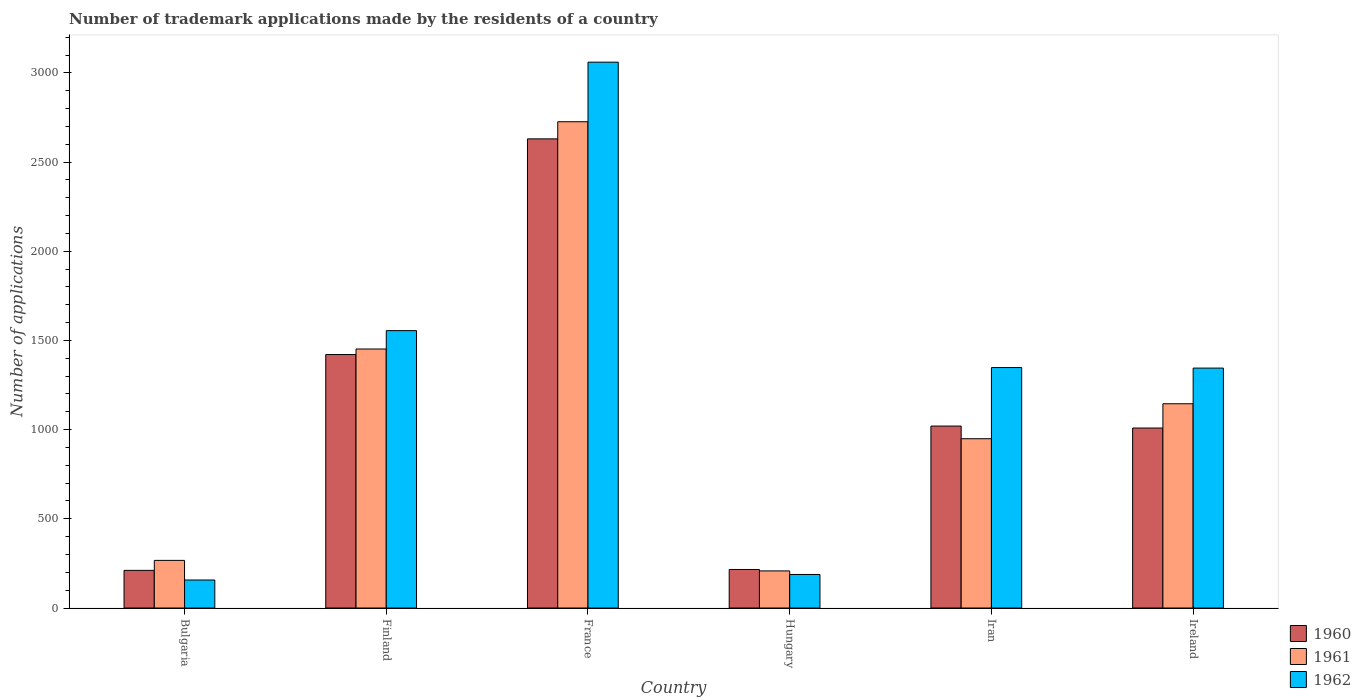How many different coloured bars are there?
Provide a short and direct response. 3. How many groups of bars are there?
Provide a short and direct response. 6. What is the label of the 1st group of bars from the left?
Keep it short and to the point. Bulgaria. What is the number of trademark applications made by the residents in 1961 in Iran?
Make the answer very short. 949. Across all countries, what is the maximum number of trademark applications made by the residents in 1962?
Ensure brevity in your answer.  3060. Across all countries, what is the minimum number of trademark applications made by the residents in 1962?
Your response must be concise. 157. In which country was the number of trademark applications made by the residents in 1961 maximum?
Your answer should be very brief. France. In which country was the number of trademark applications made by the residents in 1960 minimum?
Offer a terse response. Bulgaria. What is the total number of trademark applications made by the residents in 1960 in the graph?
Provide a short and direct response. 6507. What is the difference between the number of trademark applications made by the residents in 1961 in Bulgaria and that in Ireland?
Your answer should be compact. -878. What is the difference between the number of trademark applications made by the residents in 1961 in France and the number of trademark applications made by the residents in 1960 in Finland?
Your answer should be compact. 1305. What is the average number of trademark applications made by the residents in 1962 per country?
Offer a terse response. 1275.5. What is the difference between the number of trademark applications made by the residents of/in 1961 and number of trademark applications made by the residents of/in 1962 in Ireland?
Provide a short and direct response. -200. In how many countries, is the number of trademark applications made by the residents in 1962 greater than 800?
Offer a terse response. 4. What is the ratio of the number of trademark applications made by the residents in 1960 in Bulgaria to that in Finland?
Offer a very short reply. 0.15. Is the number of trademark applications made by the residents in 1962 in France less than that in Hungary?
Your response must be concise. No. What is the difference between the highest and the second highest number of trademark applications made by the residents in 1960?
Your answer should be very brief. -401. What is the difference between the highest and the lowest number of trademark applications made by the residents in 1960?
Keep it short and to the point. 2419. What does the 3rd bar from the right in Hungary represents?
Offer a terse response. 1960. Is it the case that in every country, the sum of the number of trademark applications made by the residents in 1962 and number of trademark applications made by the residents in 1961 is greater than the number of trademark applications made by the residents in 1960?
Your answer should be very brief. Yes. What is the difference between two consecutive major ticks on the Y-axis?
Provide a succinct answer. 500. Does the graph contain any zero values?
Your response must be concise. No. How are the legend labels stacked?
Provide a succinct answer. Vertical. What is the title of the graph?
Provide a succinct answer. Number of trademark applications made by the residents of a country. Does "2007" appear as one of the legend labels in the graph?
Make the answer very short. No. What is the label or title of the X-axis?
Keep it short and to the point. Country. What is the label or title of the Y-axis?
Your answer should be compact. Number of applications. What is the Number of applications in 1960 in Bulgaria?
Provide a succinct answer. 211. What is the Number of applications of 1961 in Bulgaria?
Ensure brevity in your answer.  267. What is the Number of applications of 1962 in Bulgaria?
Make the answer very short. 157. What is the Number of applications in 1960 in Finland?
Ensure brevity in your answer.  1421. What is the Number of applications in 1961 in Finland?
Make the answer very short. 1452. What is the Number of applications of 1962 in Finland?
Give a very brief answer. 1555. What is the Number of applications of 1960 in France?
Offer a terse response. 2630. What is the Number of applications in 1961 in France?
Make the answer very short. 2726. What is the Number of applications of 1962 in France?
Provide a succinct answer. 3060. What is the Number of applications of 1960 in Hungary?
Make the answer very short. 216. What is the Number of applications in 1961 in Hungary?
Your response must be concise. 208. What is the Number of applications of 1962 in Hungary?
Provide a succinct answer. 188. What is the Number of applications in 1960 in Iran?
Make the answer very short. 1020. What is the Number of applications in 1961 in Iran?
Keep it short and to the point. 949. What is the Number of applications of 1962 in Iran?
Provide a short and direct response. 1348. What is the Number of applications in 1960 in Ireland?
Make the answer very short. 1009. What is the Number of applications of 1961 in Ireland?
Ensure brevity in your answer.  1145. What is the Number of applications in 1962 in Ireland?
Offer a very short reply. 1345. Across all countries, what is the maximum Number of applications of 1960?
Make the answer very short. 2630. Across all countries, what is the maximum Number of applications in 1961?
Provide a short and direct response. 2726. Across all countries, what is the maximum Number of applications in 1962?
Offer a very short reply. 3060. Across all countries, what is the minimum Number of applications of 1960?
Offer a very short reply. 211. Across all countries, what is the minimum Number of applications in 1961?
Give a very brief answer. 208. Across all countries, what is the minimum Number of applications of 1962?
Offer a terse response. 157. What is the total Number of applications in 1960 in the graph?
Your response must be concise. 6507. What is the total Number of applications of 1961 in the graph?
Make the answer very short. 6747. What is the total Number of applications of 1962 in the graph?
Give a very brief answer. 7653. What is the difference between the Number of applications of 1960 in Bulgaria and that in Finland?
Provide a short and direct response. -1210. What is the difference between the Number of applications of 1961 in Bulgaria and that in Finland?
Give a very brief answer. -1185. What is the difference between the Number of applications of 1962 in Bulgaria and that in Finland?
Give a very brief answer. -1398. What is the difference between the Number of applications in 1960 in Bulgaria and that in France?
Offer a very short reply. -2419. What is the difference between the Number of applications in 1961 in Bulgaria and that in France?
Offer a very short reply. -2459. What is the difference between the Number of applications of 1962 in Bulgaria and that in France?
Your response must be concise. -2903. What is the difference between the Number of applications of 1960 in Bulgaria and that in Hungary?
Make the answer very short. -5. What is the difference between the Number of applications in 1961 in Bulgaria and that in Hungary?
Your answer should be compact. 59. What is the difference between the Number of applications of 1962 in Bulgaria and that in Hungary?
Offer a terse response. -31. What is the difference between the Number of applications of 1960 in Bulgaria and that in Iran?
Your answer should be very brief. -809. What is the difference between the Number of applications in 1961 in Bulgaria and that in Iran?
Make the answer very short. -682. What is the difference between the Number of applications in 1962 in Bulgaria and that in Iran?
Give a very brief answer. -1191. What is the difference between the Number of applications in 1960 in Bulgaria and that in Ireland?
Your response must be concise. -798. What is the difference between the Number of applications of 1961 in Bulgaria and that in Ireland?
Give a very brief answer. -878. What is the difference between the Number of applications of 1962 in Bulgaria and that in Ireland?
Make the answer very short. -1188. What is the difference between the Number of applications of 1960 in Finland and that in France?
Offer a very short reply. -1209. What is the difference between the Number of applications in 1961 in Finland and that in France?
Offer a very short reply. -1274. What is the difference between the Number of applications in 1962 in Finland and that in France?
Keep it short and to the point. -1505. What is the difference between the Number of applications of 1960 in Finland and that in Hungary?
Your answer should be compact. 1205. What is the difference between the Number of applications in 1961 in Finland and that in Hungary?
Your answer should be compact. 1244. What is the difference between the Number of applications in 1962 in Finland and that in Hungary?
Keep it short and to the point. 1367. What is the difference between the Number of applications of 1960 in Finland and that in Iran?
Keep it short and to the point. 401. What is the difference between the Number of applications in 1961 in Finland and that in Iran?
Offer a terse response. 503. What is the difference between the Number of applications in 1962 in Finland and that in Iran?
Give a very brief answer. 207. What is the difference between the Number of applications of 1960 in Finland and that in Ireland?
Keep it short and to the point. 412. What is the difference between the Number of applications in 1961 in Finland and that in Ireland?
Provide a succinct answer. 307. What is the difference between the Number of applications of 1962 in Finland and that in Ireland?
Your response must be concise. 210. What is the difference between the Number of applications in 1960 in France and that in Hungary?
Make the answer very short. 2414. What is the difference between the Number of applications in 1961 in France and that in Hungary?
Offer a very short reply. 2518. What is the difference between the Number of applications of 1962 in France and that in Hungary?
Your answer should be very brief. 2872. What is the difference between the Number of applications of 1960 in France and that in Iran?
Offer a terse response. 1610. What is the difference between the Number of applications of 1961 in France and that in Iran?
Offer a very short reply. 1777. What is the difference between the Number of applications of 1962 in France and that in Iran?
Ensure brevity in your answer.  1712. What is the difference between the Number of applications in 1960 in France and that in Ireland?
Provide a succinct answer. 1621. What is the difference between the Number of applications in 1961 in France and that in Ireland?
Your answer should be very brief. 1581. What is the difference between the Number of applications of 1962 in France and that in Ireland?
Offer a terse response. 1715. What is the difference between the Number of applications in 1960 in Hungary and that in Iran?
Offer a very short reply. -804. What is the difference between the Number of applications of 1961 in Hungary and that in Iran?
Keep it short and to the point. -741. What is the difference between the Number of applications of 1962 in Hungary and that in Iran?
Keep it short and to the point. -1160. What is the difference between the Number of applications in 1960 in Hungary and that in Ireland?
Keep it short and to the point. -793. What is the difference between the Number of applications of 1961 in Hungary and that in Ireland?
Your answer should be very brief. -937. What is the difference between the Number of applications in 1962 in Hungary and that in Ireland?
Provide a succinct answer. -1157. What is the difference between the Number of applications in 1961 in Iran and that in Ireland?
Keep it short and to the point. -196. What is the difference between the Number of applications of 1960 in Bulgaria and the Number of applications of 1961 in Finland?
Give a very brief answer. -1241. What is the difference between the Number of applications of 1960 in Bulgaria and the Number of applications of 1962 in Finland?
Your answer should be very brief. -1344. What is the difference between the Number of applications of 1961 in Bulgaria and the Number of applications of 1962 in Finland?
Offer a very short reply. -1288. What is the difference between the Number of applications in 1960 in Bulgaria and the Number of applications in 1961 in France?
Ensure brevity in your answer.  -2515. What is the difference between the Number of applications of 1960 in Bulgaria and the Number of applications of 1962 in France?
Give a very brief answer. -2849. What is the difference between the Number of applications in 1961 in Bulgaria and the Number of applications in 1962 in France?
Ensure brevity in your answer.  -2793. What is the difference between the Number of applications in 1961 in Bulgaria and the Number of applications in 1962 in Hungary?
Give a very brief answer. 79. What is the difference between the Number of applications of 1960 in Bulgaria and the Number of applications of 1961 in Iran?
Your answer should be compact. -738. What is the difference between the Number of applications in 1960 in Bulgaria and the Number of applications in 1962 in Iran?
Give a very brief answer. -1137. What is the difference between the Number of applications of 1961 in Bulgaria and the Number of applications of 1962 in Iran?
Offer a terse response. -1081. What is the difference between the Number of applications of 1960 in Bulgaria and the Number of applications of 1961 in Ireland?
Provide a short and direct response. -934. What is the difference between the Number of applications of 1960 in Bulgaria and the Number of applications of 1962 in Ireland?
Provide a succinct answer. -1134. What is the difference between the Number of applications in 1961 in Bulgaria and the Number of applications in 1962 in Ireland?
Offer a terse response. -1078. What is the difference between the Number of applications of 1960 in Finland and the Number of applications of 1961 in France?
Make the answer very short. -1305. What is the difference between the Number of applications of 1960 in Finland and the Number of applications of 1962 in France?
Your answer should be very brief. -1639. What is the difference between the Number of applications of 1961 in Finland and the Number of applications of 1962 in France?
Ensure brevity in your answer.  -1608. What is the difference between the Number of applications of 1960 in Finland and the Number of applications of 1961 in Hungary?
Your answer should be very brief. 1213. What is the difference between the Number of applications of 1960 in Finland and the Number of applications of 1962 in Hungary?
Provide a short and direct response. 1233. What is the difference between the Number of applications in 1961 in Finland and the Number of applications in 1962 in Hungary?
Give a very brief answer. 1264. What is the difference between the Number of applications of 1960 in Finland and the Number of applications of 1961 in Iran?
Your response must be concise. 472. What is the difference between the Number of applications of 1960 in Finland and the Number of applications of 1962 in Iran?
Ensure brevity in your answer.  73. What is the difference between the Number of applications in 1961 in Finland and the Number of applications in 1962 in Iran?
Make the answer very short. 104. What is the difference between the Number of applications of 1960 in Finland and the Number of applications of 1961 in Ireland?
Ensure brevity in your answer.  276. What is the difference between the Number of applications of 1961 in Finland and the Number of applications of 1962 in Ireland?
Make the answer very short. 107. What is the difference between the Number of applications of 1960 in France and the Number of applications of 1961 in Hungary?
Your answer should be very brief. 2422. What is the difference between the Number of applications in 1960 in France and the Number of applications in 1962 in Hungary?
Ensure brevity in your answer.  2442. What is the difference between the Number of applications in 1961 in France and the Number of applications in 1962 in Hungary?
Ensure brevity in your answer.  2538. What is the difference between the Number of applications in 1960 in France and the Number of applications in 1961 in Iran?
Offer a terse response. 1681. What is the difference between the Number of applications of 1960 in France and the Number of applications of 1962 in Iran?
Keep it short and to the point. 1282. What is the difference between the Number of applications of 1961 in France and the Number of applications of 1962 in Iran?
Give a very brief answer. 1378. What is the difference between the Number of applications in 1960 in France and the Number of applications in 1961 in Ireland?
Provide a succinct answer. 1485. What is the difference between the Number of applications in 1960 in France and the Number of applications in 1962 in Ireland?
Your answer should be compact. 1285. What is the difference between the Number of applications of 1961 in France and the Number of applications of 1962 in Ireland?
Offer a terse response. 1381. What is the difference between the Number of applications in 1960 in Hungary and the Number of applications in 1961 in Iran?
Your answer should be compact. -733. What is the difference between the Number of applications in 1960 in Hungary and the Number of applications in 1962 in Iran?
Your response must be concise. -1132. What is the difference between the Number of applications in 1961 in Hungary and the Number of applications in 1962 in Iran?
Provide a succinct answer. -1140. What is the difference between the Number of applications of 1960 in Hungary and the Number of applications of 1961 in Ireland?
Give a very brief answer. -929. What is the difference between the Number of applications in 1960 in Hungary and the Number of applications in 1962 in Ireland?
Keep it short and to the point. -1129. What is the difference between the Number of applications of 1961 in Hungary and the Number of applications of 1962 in Ireland?
Provide a short and direct response. -1137. What is the difference between the Number of applications of 1960 in Iran and the Number of applications of 1961 in Ireland?
Your response must be concise. -125. What is the difference between the Number of applications of 1960 in Iran and the Number of applications of 1962 in Ireland?
Offer a very short reply. -325. What is the difference between the Number of applications in 1961 in Iran and the Number of applications in 1962 in Ireland?
Make the answer very short. -396. What is the average Number of applications of 1960 per country?
Your answer should be very brief. 1084.5. What is the average Number of applications of 1961 per country?
Keep it short and to the point. 1124.5. What is the average Number of applications in 1962 per country?
Your answer should be compact. 1275.5. What is the difference between the Number of applications of 1960 and Number of applications of 1961 in Bulgaria?
Your response must be concise. -56. What is the difference between the Number of applications in 1960 and Number of applications in 1962 in Bulgaria?
Give a very brief answer. 54. What is the difference between the Number of applications in 1961 and Number of applications in 1962 in Bulgaria?
Provide a short and direct response. 110. What is the difference between the Number of applications in 1960 and Number of applications in 1961 in Finland?
Make the answer very short. -31. What is the difference between the Number of applications of 1960 and Number of applications of 1962 in Finland?
Provide a short and direct response. -134. What is the difference between the Number of applications in 1961 and Number of applications in 1962 in Finland?
Make the answer very short. -103. What is the difference between the Number of applications in 1960 and Number of applications in 1961 in France?
Keep it short and to the point. -96. What is the difference between the Number of applications in 1960 and Number of applications in 1962 in France?
Keep it short and to the point. -430. What is the difference between the Number of applications in 1961 and Number of applications in 1962 in France?
Provide a succinct answer. -334. What is the difference between the Number of applications of 1960 and Number of applications of 1962 in Hungary?
Provide a succinct answer. 28. What is the difference between the Number of applications of 1961 and Number of applications of 1962 in Hungary?
Give a very brief answer. 20. What is the difference between the Number of applications of 1960 and Number of applications of 1961 in Iran?
Your response must be concise. 71. What is the difference between the Number of applications of 1960 and Number of applications of 1962 in Iran?
Your answer should be very brief. -328. What is the difference between the Number of applications in 1961 and Number of applications in 1962 in Iran?
Offer a terse response. -399. What is the difference between the Number of applications in 1960 and Number of applications in 1961 in Ireland?
Offer a very short reply. -136. What is the difference between the Number of applications in 1960 and Number of applications in 1962 in Ireland?
Provide a succinct answer. -336. What is the difference between the Number of applications in 1961 and Number of applications in 1962 in Ireland?
Offer a terse response. -200. What is the ratio of the Number of applications of 1960 in Bulgaria to that in Finland?
Offer a very short reply. 0.15. What is the ratio of the Number of applications in 1961 in Bulgaria to that in Finland?
Provide a short and direct response. 0.18. What is the ratio of the Number of applications of 1962 in Bulgaria to that in Finland?
Make the answer very short. 0.1. What is the ratio of the Number of applications in 1960 in Bulgaria to that in France?
Provide a short and direct response. 0.08. What is the ratio of the Number of applications of 1961 in Bulgaria to that in France?
Keep it short and to the point. 0.1. What is the ratio of the Number of applications of 1962 in Bulgaria to that in France?
Your answer should be very brief. 0.05. What is the ratio of the Number of applications in 1960 in Bulgaria to that in Hungary?
Keep it short and to the point. 0.98. What is the ratio of the Number of applications of 1961 in Bulgaria to that in Hungary?
Ensure brevity in your answer.  1.28. What is the ratio of the Number of applications of 1962 in Bulgaria to that in Hungary?
Your answer should be compact. 0.84. What is the ratio of the Number of applications of 1960 in Bulgaria to that in Iran?
Offer a terse response. 0.21. What is the ratio of the Number of applications of 1961 in Bulgaria to that in Iran?
Provide a succinct answer. 0.28. What is the ratio of the Number of applications in 1962 in Bulgaria to that in Iran?
Give a very brief answer. 0.12. What is the ratio of the Number of applications of 1960 in Bulgaria to that in Ireland?
Provide a short and direct response. 0.21. What is the ratio of the Number of applications in 1961 in Bulgaria to that in Ireland?
Offer a terse response. 0.23. What is the ratio of the Number of applications in 1962 in Bulgaria to that in Ireland?
Offer a terse response. 0.12. What is the ratio of the Number of applications in 1960 in Finland to that in France?
Ensure brevity in your answer.  0.54. What is the ratio of the Number of applications in 1961 in Finland to that in France?
Offer a very short reply. 0.53. What is the ratio of the Number of applications in 1962 in Finland to that in France?
Provide a short and direct response. 0.51. What is the ratio of the Number of applications of 1960 in Finland to that in Hungary?
Make the answer very short. 6.58. What is the ratio of the Number of applications in 1961 in Finland to that in Hungary?
Provide a short and direct response. 6.98. What is the ratio of the Number of applications in 1962 in Finland to that in Hungary?
Your answer should be compact. 8.27. What is the ratio of the Number of applications in 1960 in Finland to that in Iran?
Give a very brief answer. 1.39. What is the ratio of the Number of applications in 1961 in Finland to that in Iran?
Provide a succinct answer. 1.53. What is the ratio of the Number of applications of 1962 in Finland to that in Iran?
Make the answer very short. 1.15. What is the ratio of the Number of applications in 1960 in Finland to that in Ireland?
Make the answer very short. 1.41. What is the ratio of the Number of applications of 1961 in Finland to that in Ireland?
Make the answer very short. 1.27. What is the ratio of the Number of applications in 1962 in Finland to that in Ireland?
Keep it short and to the point. 1.16. What is the ratio of the Number of applications in 1960 in France to that in Hungary?
Provide a short and direct response. 12.18. What is the ratio of the Number of applications in 1961 in France to that in Hungary?
Provide a succinct answer. 13.11. What is the ratio of the Number of applications in 1962 in France to that in Hungary?
Ensure brevity in your answer.  16.28. What is the ratio of the Number of applications of 1960 in France to that in Iran?
Your answer should be compact. 2.58. What is the ratio of the Number of applications in 1961 in France to that in Iran?
Your answer should be compact. 2.87. What is the ratio of the Number of applications of 1962 in France to that in Iran?
Your answer should be very brief. 2.27. What is the ratio of the Number of applications in 1960 in France to that in Ireland?
Offer a terse response. 2.61. What is the ratio of the Number of applications in 1961 in France to that in Ireland?
Ensure brevity in your answer.  2.38. What is the ratio of the Number of applications in 1962 in France to that in Ireland?
Your answer should be very brief. 2.28. What is the ratio of the Number of applications in 1960 in Hungary to that in Iran?
Provide a short and direct response. 0.21. What is the ratio of the Number of applications in 1961 in Hungary to that in Iran?
Keep it short and to the point. 0.22. What is the ratio of the Number of applications in 1962 in Hungary to that in Iran?
Your answer should be very brief. 0.14. What is the ratio of the Number of applications of 1960 in Hungary to that in Ireland?
Keep it short and to the point. 0.21. What is the ratio of the Number of applications in 1961 in Hungary to that in Ireland?
Provide a succinct answer. 0.18. What is the ratio of the Number of applications of 1962 in Hungary to that in Ireland?
Make the answer very short. 0.14. What is the ratio of the Number of applications of 1960 in Iran to that in Ireland?
Your answer should be compact. 1.01. What is the ratio of the Number of applications in 1961 in Iran to that in Ireland?
Offer a terse response. 0.83. What is the ratio of the Number of applications in 1962 in Iran to that in Ireland?
Offer a terse response. 1. What is the difference between the highest and the second highest Number of applications in 1960?
Give a very brief answer. 1209. What is the difference between the highest and the second highest Number of applications in 1961?
Offer a very short reply. 1274. What is the difference between the highest and the second highest Number of applications of 1962?
Your answer should be very brief. 1505. What is the difference between the highest and the lowest Number of applications in 1960?
Offer a terse response. 2419. What is the difference between the highest and the lowest Number of applications of 1961?
Keep it short and to the point. 2518. What is the difference between the highest and the lowest Number of applications of 1962?
Your answer should be compact. 2903. 